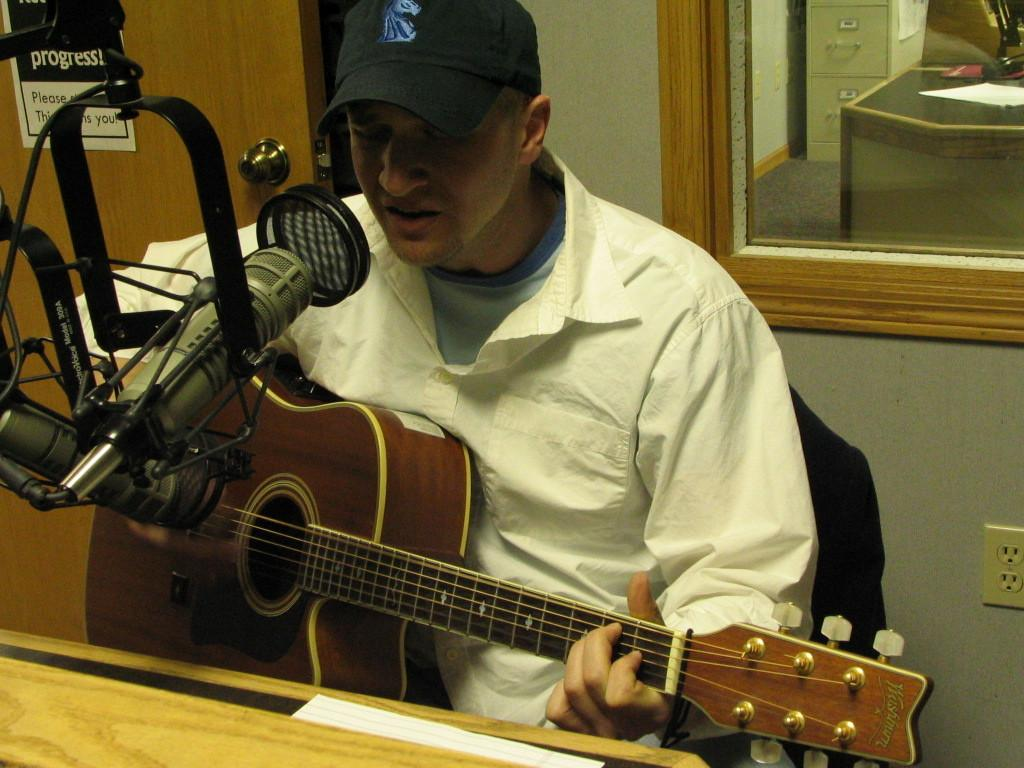Who is present in the image? There is a man in the image. What is the man doing in the image? The man is sitting on a chair in the image. What object is the man holding in his hand? The man is holding a guitar in his hand. What is in front of the man that might be used for amplifying his voice? There is a microphone with a stand in front of the man. What book is the man reading in the image? There is no book present in the image; the man is holding a guitar and sitting near a microphone. 